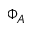Convert formula to latex. <formula><loc_0><loc_0><loc_500><loc_500>\Phi _ { A }</formula> 